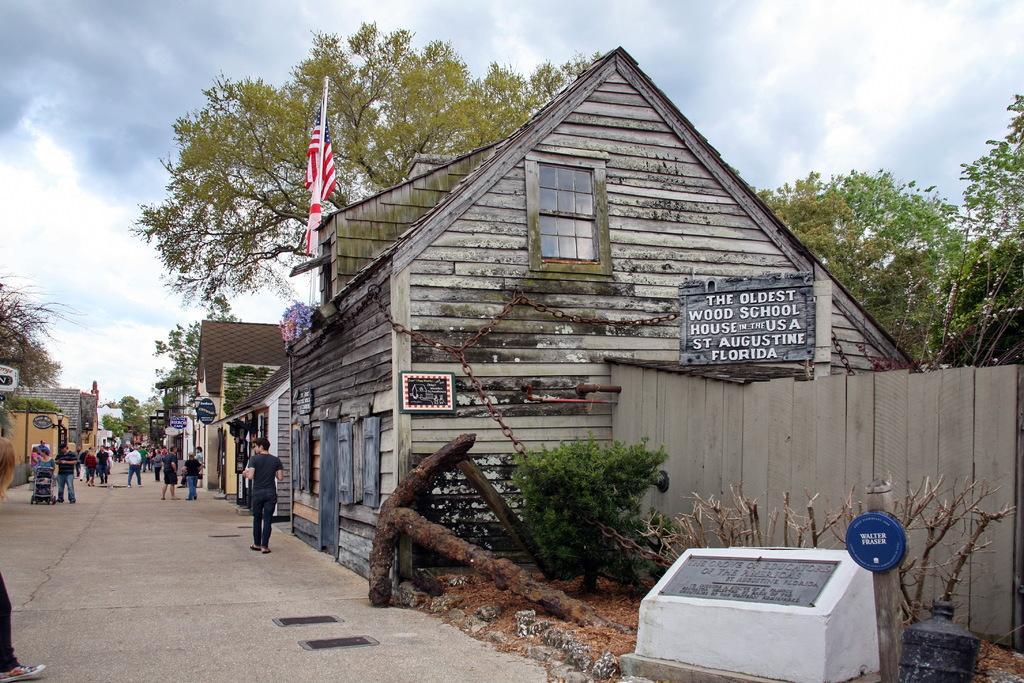Could you give a brief overview of what you see in this image? In this image I can see buildings. There are group of people, there are boards, trees and there are some other objects. In the background there is sky. 